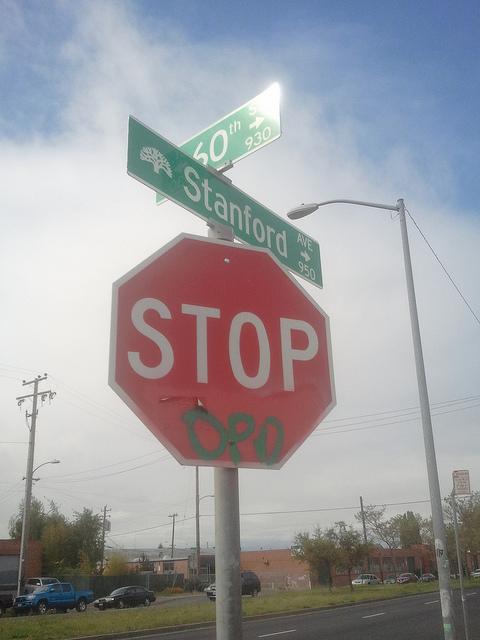What does the bottom sign say on the sign post?
Give a very brief answer. Stop. What is the cross street shown on the sign pole?
Give a very brief answer. Stanford. What is the speed limit posted on the sign?
Quick response, please. 30. The colors of these two signs are used in the flags of which country?
Quick response, please. Italy. Where is the truck parked?
Answer briefly. Street. Is there a blue truck in the background?
Short answer required. Yes. Is there graffiti on the stop sign?
Give a very brief answer. Yes. Who took this picture?
Be succinct. Person. What streets intersect?
Keep it brief. Stanford and 60th. What song is the sign and the graffiti referring to?
Keep it brief. Stop. What street name is on the top?
Quick response, please. 60th. Where are the cars?
Write a very short answer. Road. Would you take your dog for a walk along this street?
Keep it brief. Yes. Is this a 2 way stop?
Short answer required. No. What street name is shown?
Answer briefly. Stanford. 